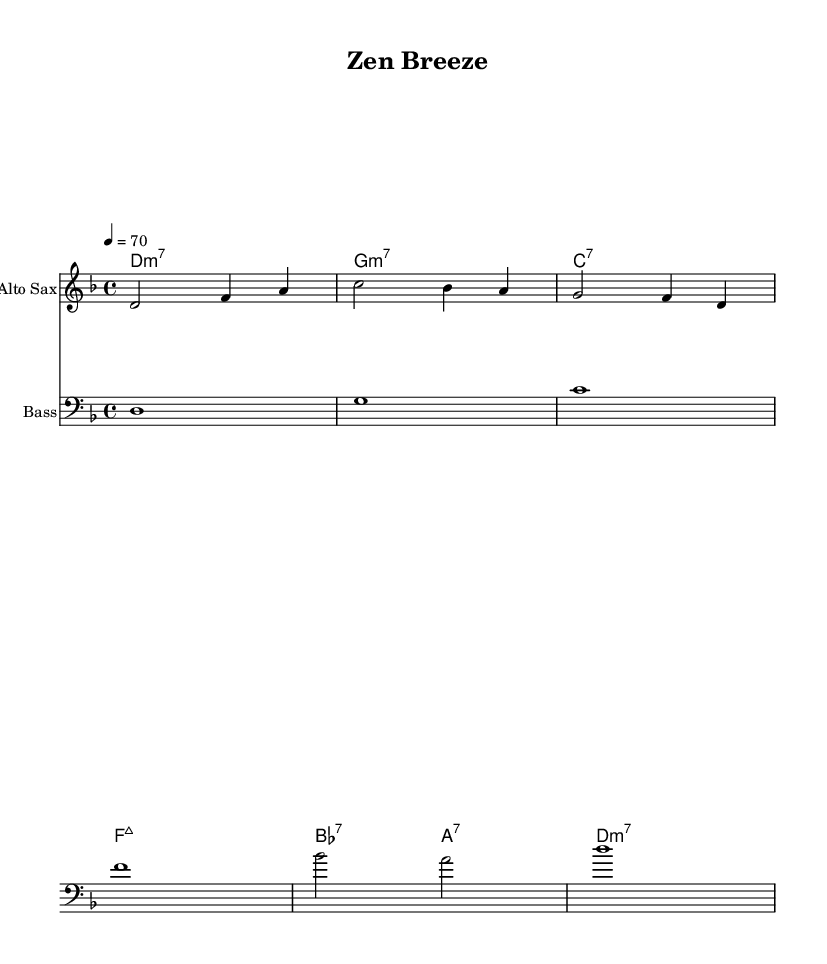What is the key signature of this music? The key signature is D minor, which is indicated by one flat (B♭) at the beginning of the staff.
Answer: D minor What is the time signature of this music? The time signature is 4/4, which can be seen at the beginning of the sheet music, indicating four beats per measure, with the quarter note receiving one beat.
Answer: 4/4 What is the tempo marking of this piece? The tempo marking is indicated as 4 = 70, which signifies that the quarter note equals 70 beats per minute.
Answer: 70 How many measures are in the melody section? By counting each measure in the melody notation provided, there are four measures in total.
Answer: 4 What type of chord is the first chord in the harmony? The first chord is a D minor seventh chord, represented as "d:m7," which is constructed from the notes D, F, A, and C.
Answer: D minor seventh How does the bass pattern compare to the melody? The bass pattern follows a root note structure that coincides with the chords played in the harmony section, emphasizing the harmonic foundation of the piece.
Answer: Coincides What kind of jazz interpretation is illustrated in this piece? The piece demonstrates a smooth jazz interpretation, characterized by the relaxed groove and melodic improvisation typical of this style, incorporating elements from traditional Buddhist chants.
Answer: Smooth jazz 